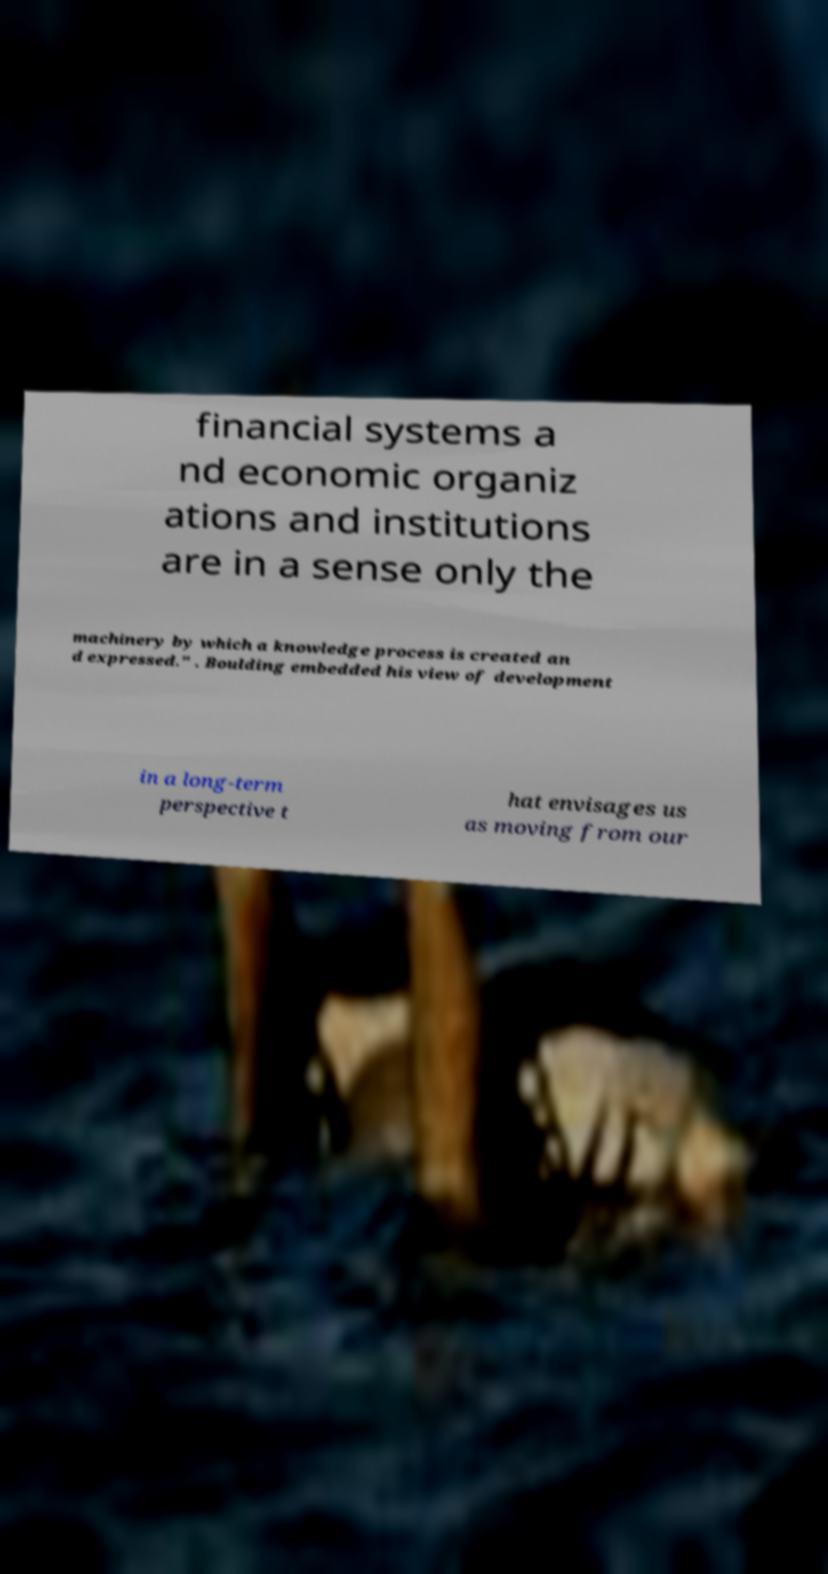Could you extract and type out the text from this image? financial systems a nd economic organiz ations and institutions are in a sense only the machinery by which a knowledge process is created an d expressed." . Boulding embedded his view of development in a long-term perspective t hat envisages us as moving from our 